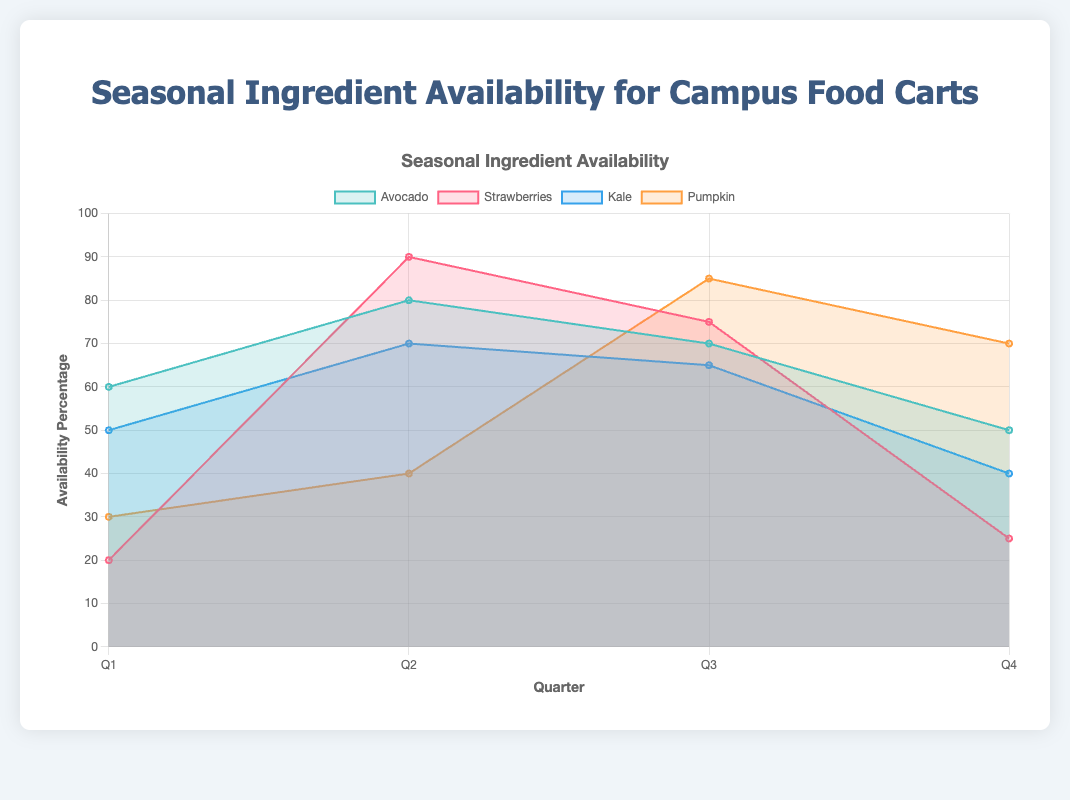What's the title of the chart? The title of the chart is displayed at the top in bold; it states the main topic of the visualization.
Answer: Seasonal Ingredient Availability for Campus Food Carts Which ingredient has the highest availability percentage in Q3? To find the highest availability in Q3, look for the peak points in the Q3 data along the y-axis for each ingredient.
Answer: Pumpkin How does the availability of Strawberries change from Q1 to Q2? Observe the y-axis values for Strawberries in Q1 and Q2 and calculate the difference between these values. Strawberries in Q1 is at 20% and rises to 90% in Q2.
Answer: Increases by 70% Which quarter shows the highest availability for Kale? Identify the quarter where Kale's line reaches its highest point on the y-axis.
Answer: Q2 What's the difference in availability percentage between Avocados in Q2 and Q4? Check the y-axis values for Avocados in Q2 and Q4, and then compute the difference: 80% in Q2 and 50% in Q4.
Answer: 30% Does any ingredient reach 100% availability in any of the quarters? Review the maximum y-axis value for each ingredient over all quarters to see if any reach 100%.
Answer: No Compare the availability trend of Pumpkin and Strawberries across the year. Check the y-axis values across all quarters for both ingredients, noting the rise and fall trends. While Strawberries peak in Q2 and decline afterwards, Pumpkin starts low, peaks in Q3, and decreases slightly in Q4.
Answer: Different trends What is the average availability of Avocados throughout the year? Add the availability percentages of Avocados for all four quarters: (60 + 80 + 70 + 50) = 260, and divide by 4 to find the average.
Answer: 65% In which quarter is the overall availability of ingredients the highest? Sum the availability percentages for all ingredients in each quarter and compare these sums. For example, Q2: Avocado (80) + Strawberries (90) + Kale (70) + Pumpkin (40) = 280.
Answer: Q2 Which ingredient shows the most fluctuation in availability throughout the year? Calculate the range (difference between the highest and lowest availability percentages) for each ingredient. For Strawberries: Max (90) - Min (20) = 70. Compare this with other ingredients.
Answer: Strawberries 